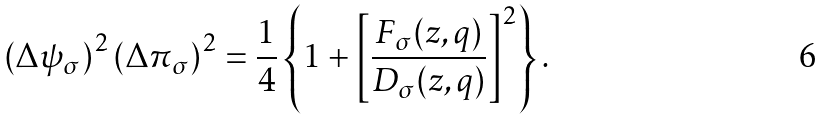<formula> <loc_0><loc_0><loc_500><loc_500>\left ( \Delta \psi _ { \sigma } \right ) ^ { 2 } \left ( \Delta \pi _ { \sigma } \right ) ^ { 2 } = \frac { 1 } { 4 } \left \{ 1 + \left [ \frac { F _ { \sigma } ( z , q ) } { D _ { \sigma } ( z , q ) } \right ] ^ { 2 } \right \} .</formula> 